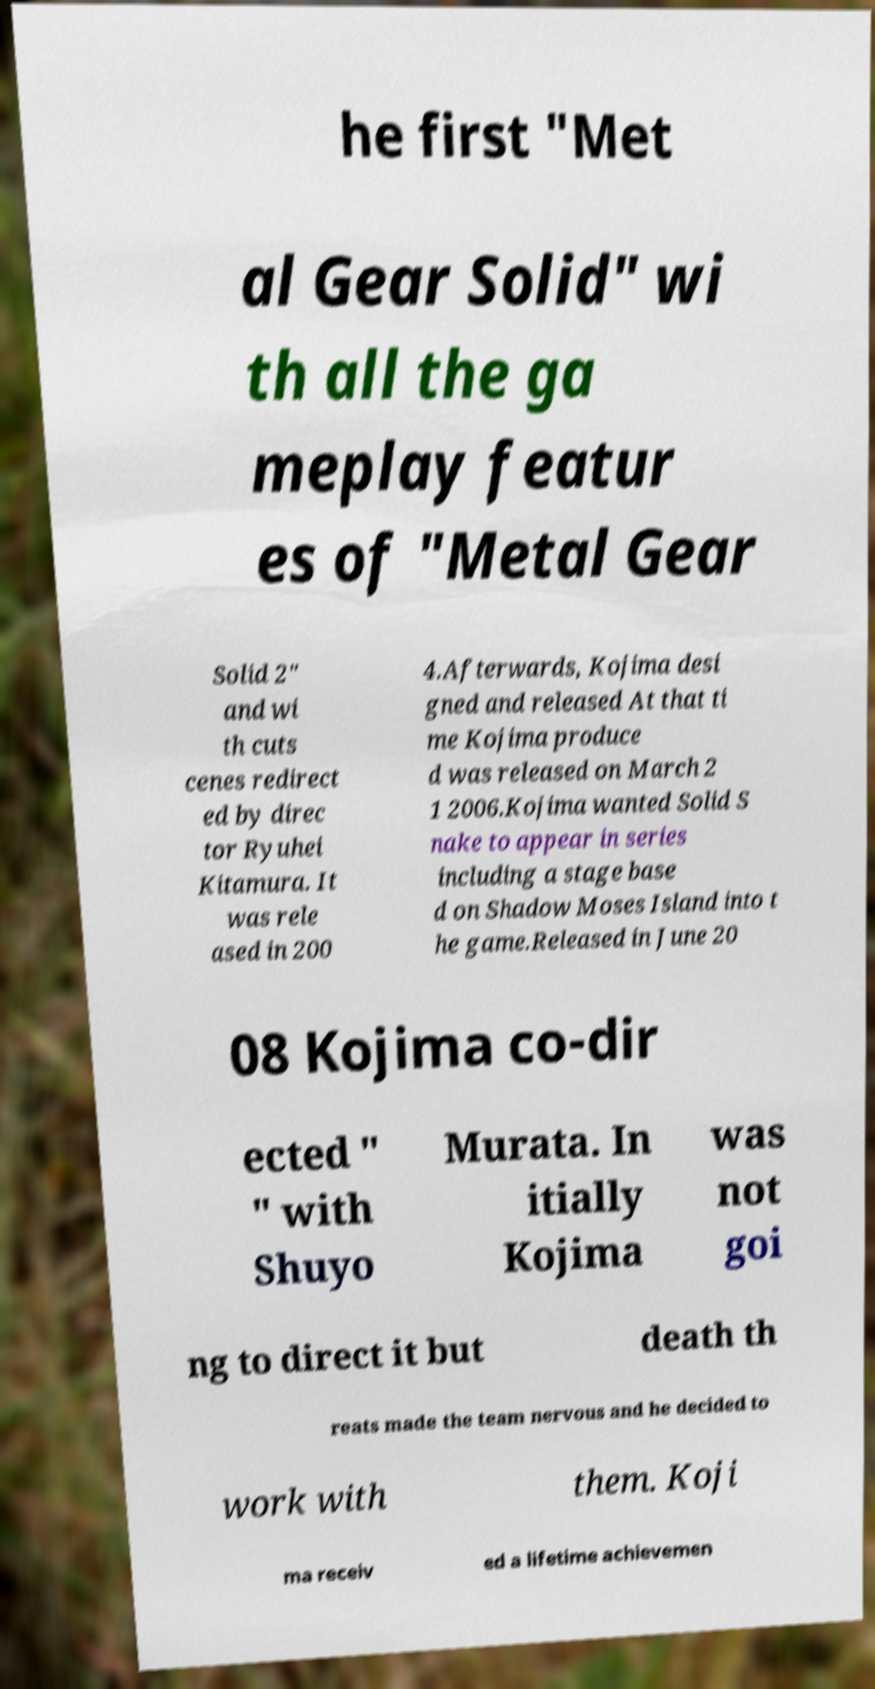For documentation purposes, I need the text within this image transcribed. Could you provide that? he first "Met al Gear Solid" wi th all the ga meplay featur es of "Metal Gear Solid 2" and wi th cuts cenes redirect ed by direc tor Ryuhei Kitamura. It was rele ased in 200 4.Afterwards, Kojima desi gned and released At that ti me Kojima produce d was released on March 2 1 2006.Kojima wanted Solid S nake to appear in series including a stage base d on Shadow Moses Island into t he game.Released in June 20 08 Kojima co-dir ected " " with Shuyo Murata. In itially Kojima was not goi ng to direct it but death th reats made the team nervous and he decided to work with them. Koji ma receiv ed a lifetime achievemen 